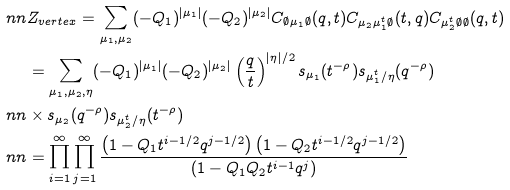<formula> <loc_0><loc_0><loc_500><loc_500>\ n n & Z _ { v e r t e x } = \sum _ { \mu _ { 1 } , \mu _ { 2 } } ( - Q _ { 1 } ) ^ { | \mu _ { 1 } | } ( - Q _ { 2 } ) ^ { | \mu _ { 2 } | } C _ { \emptyset \mu _ { 1 } \emptyset } ( q , t ) C _ { \mu _ { 2 } \mu _ { 1 } ^ { t } \emptyset } ( t , q ) C _ { \mu _ { 2 } ^ { t } \emptyset \emptyset } ( q , t ) \\ & = \sum _ { \mu _ { 1 } , \mu _ { 2 } , \eta } ( - Q _ { 1 } ) ^ { | \mu _ { 1 } | } ( - Q _ { 2 } ) ^ { | \mu _ { 2 } | } \left ( \frac { q } { t } \right ) ^ { | \eta | / 2 } s _ { \mu _ { 1 } } ( t ^ { - \rho } ) s _ { \mu _ { 1 } ^ { t } / \eta } ( q ^ { - \rho } ) \\ \ n n & \times s _ { \mu _ { 2 } } ( q ^ { - \rho } ) s _ { \mu _ { 2 } ^ { t } / \eta } ( t ^ { - \rho } ) \\ \ n n & = \prod _ { i = 1 } ^ { \infty } \prod _ { j = 1 } ^ { \infty } \frac { \left ( 1 - Q _ { 1 } t ^ { i - 1 / 2 } q ^ { j - 1 / 2 } \right ) \left ( 1 - Q _ { 2 } t ^ { i - 1 / 2 } q ^ { j - 1 / 2 } \right ) } { \left ( 1 - Q _ { 1 } Q _ { 2 } t ^ { i - 1 } q ^ { j } \right ) }</formula> 